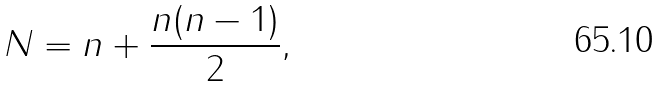Convert formula to latex. <formula><loc_0><loc_0><loc_500><loc_500>N = n + \frac { n ( n - 1 ) } { 2 } ,</formula> 